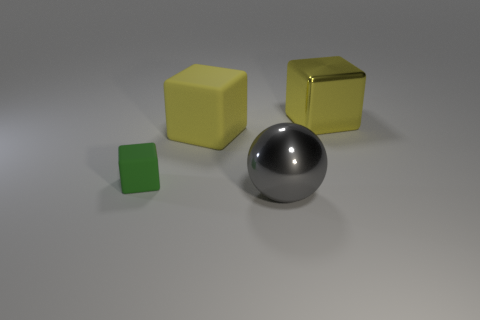Could the arrangement of these objects have a special meaning? The arrangement might not have a particular meaning, but it could be interpreted as an artistic composition or a simplified model representing atoms in a molecule, with the spherical object as the nucleus and the cubes as surrounding particles. 